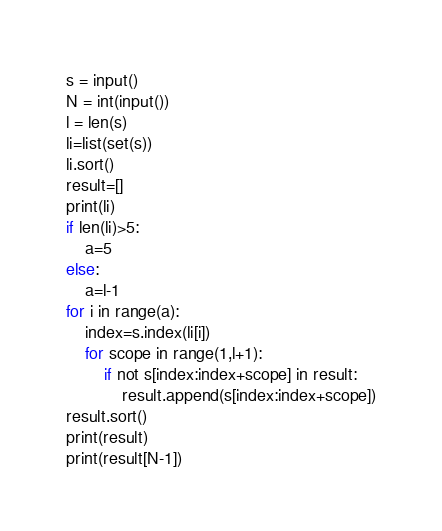<code> <loc_0><loc_0><loc_500><loc_500><_Python_>s = input()
N = int(input())
l = len(s)
li=list(set(s))
li.sort()
result=[]
print(li)
if len(li)>5:
    a=5
else:
    a=l-1
for i in range(a):
    index=s.index(li[i])
    for scope in range(1,l+1):
        if not s[index:index+scope] in result:
            result.append(s[index:index+scope])
result.sort()
print(result)
print(result[N-1])</code> 